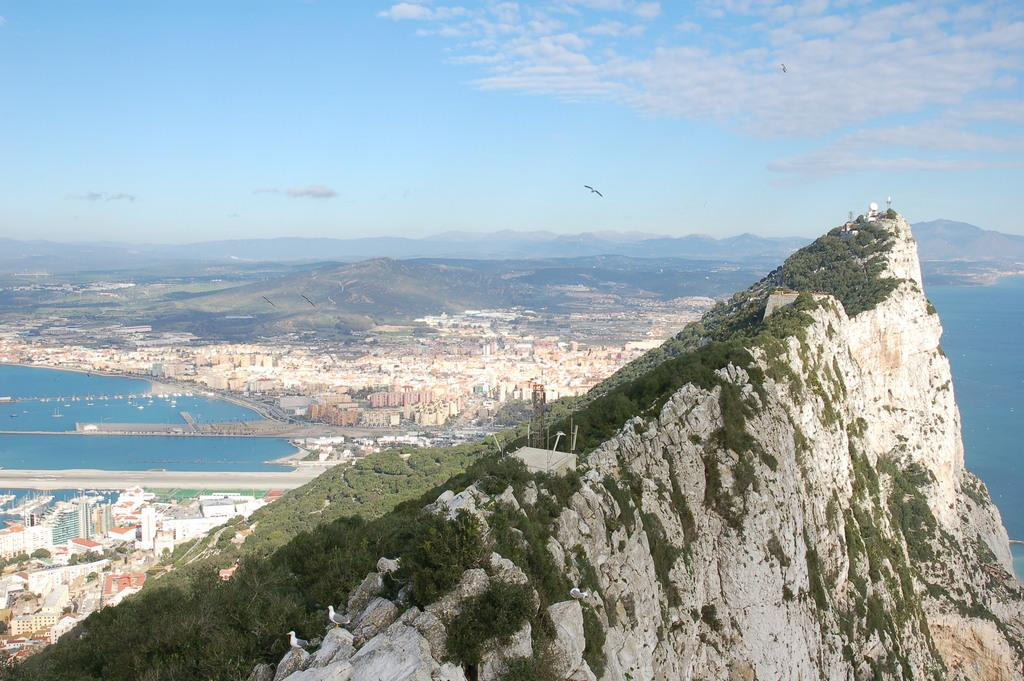What type of landscape is depicted in the image? The image features hills, trees, and a river. Are there any man-made structures in the image? Yes, there are buildings in the image. What is happening in the sky in the image? Birds are flying in the air, and there are clouds visible. What can be seen in the background of the image? The sky is visible in the background, with clouds present. What type of coach can be seen driving up the hill in the image? There is no coach present in the image; it features hills, trees, buildings, a river, birds, and clouds. 